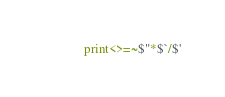Convert code to text. <code><loc_0><loc_0><loc_500><loc_500><_Perl_>print<>=~$"*$`/$'</code> 